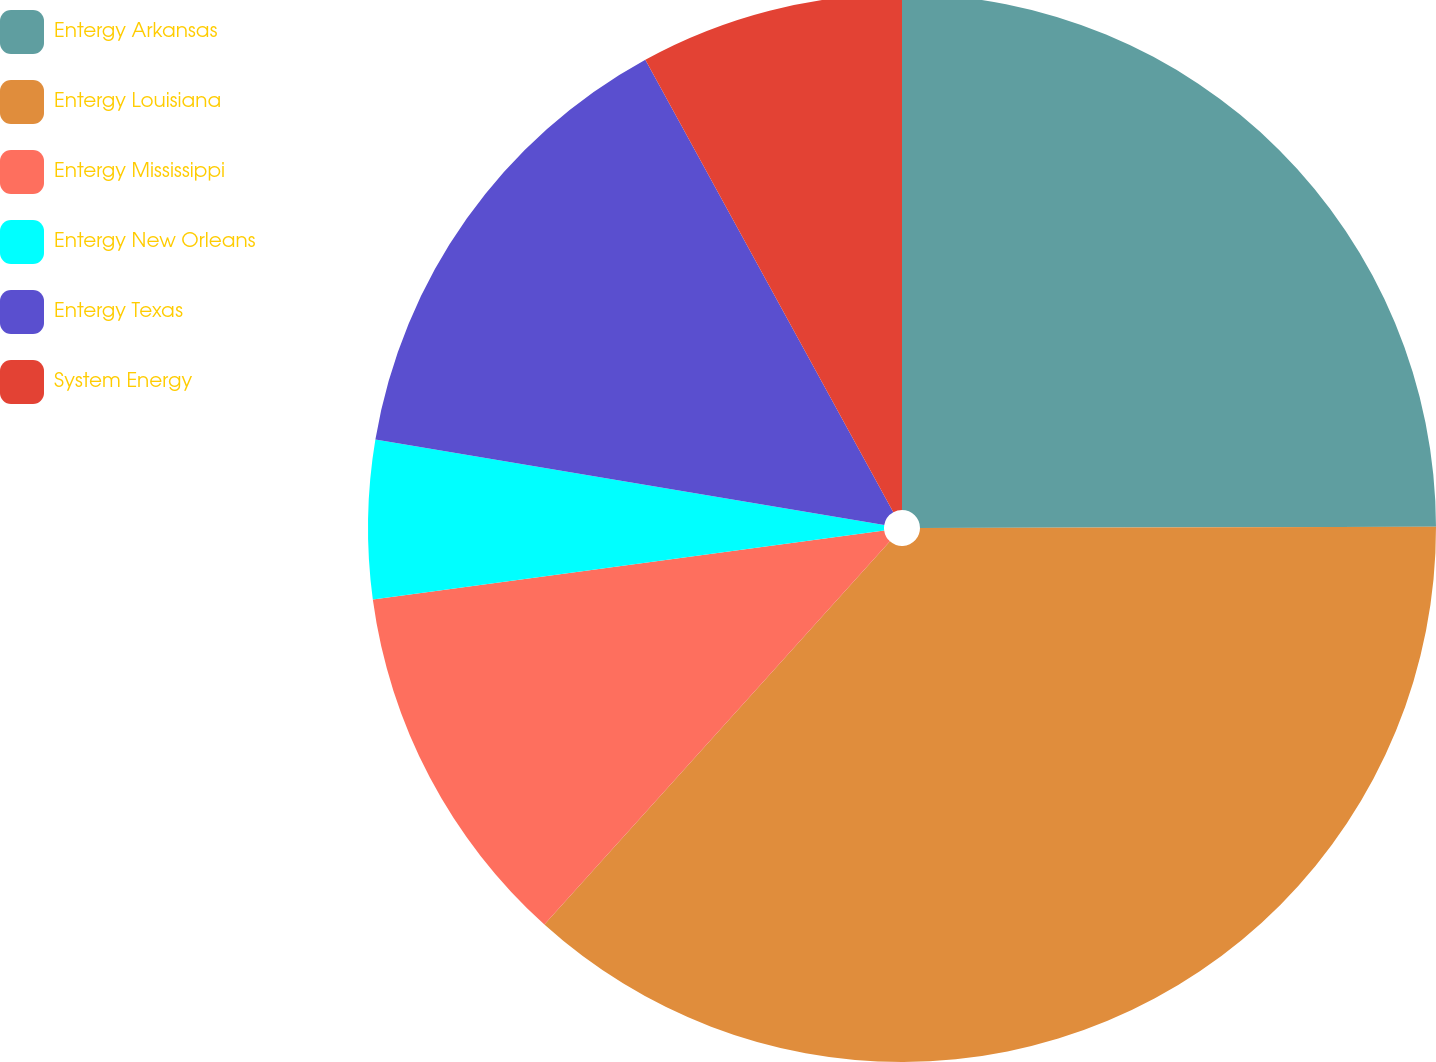<chart> <loc_0><loc_0><loc_500><loc_500><pie_chart><fcel>Entergy Arkansas<fcel>Entergy Louisiana<fcel>Entergy Mississippi<fcel>Entergy New Orleans<fcel>Entergy Texas<fcel>System Energy<nl><fcel>24.96%<fcel>36.72%<fcel>11.18%<fcel>4.79%<fcel>14.37%<fcel>7.98%<nl></chart> 